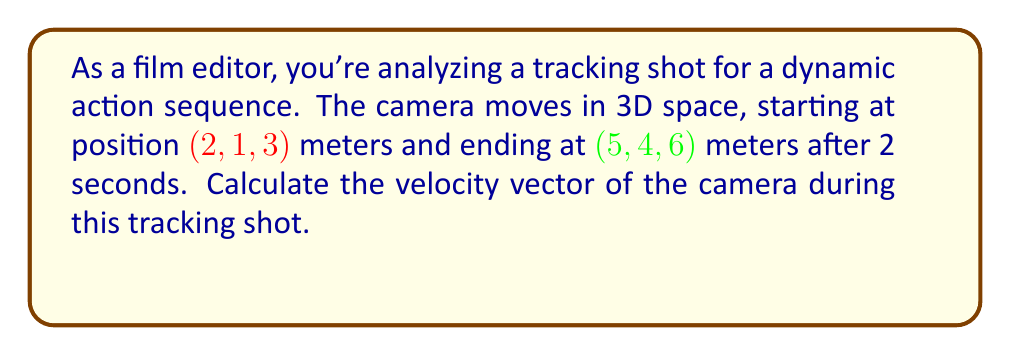Show me your answer to this math problem. To calculate the velocity vector, we need to follow these steps:

1) First, let's find the displacement vector:
   $$\vec{d} = \vec{p}_f - \vec{p}_i = (5,4,6) - (2,1,3) = (3,3,3)$$ meters

2) The velocity vector is the displacement vector divided by the time taken:
   $$\vec{v} = \frac{\vec{d}}{t}$$

3) We know the time taken is 2 seconds, so:
   $$\vec{v} = \frac{(3,3,3)}{2} = (\frac{3}{2},\frac{3}{2},\frac{3}{2})$$ meters per second

4) Simplifying:
   $$\vec{v} = (1.5, 1.5, 1.5)$$ meters per second

This velocity vector represents the constant speed and direction of the camera during the tracking shot.
Answer: $$(1.5, 1.5, 1.5)$$ m/s 